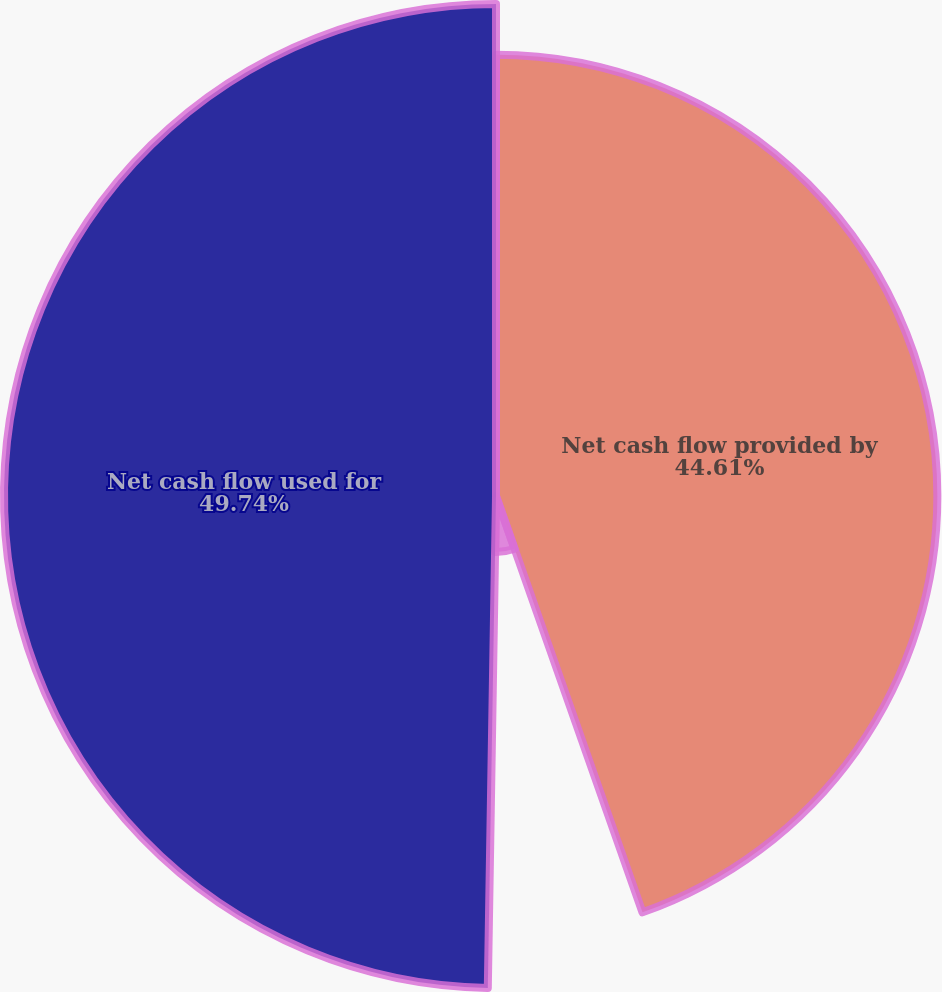Convert chart. <chart><loc_0><loc_0><loc_500><loc_500><pie_chart><fcel>Net cash flow provided by<fcel>Net cash flow provided<fcel>Net cash flow used for<nl><fcel>44.61%<fcel>5.65%<fcel>49.73%<nl></chart> 